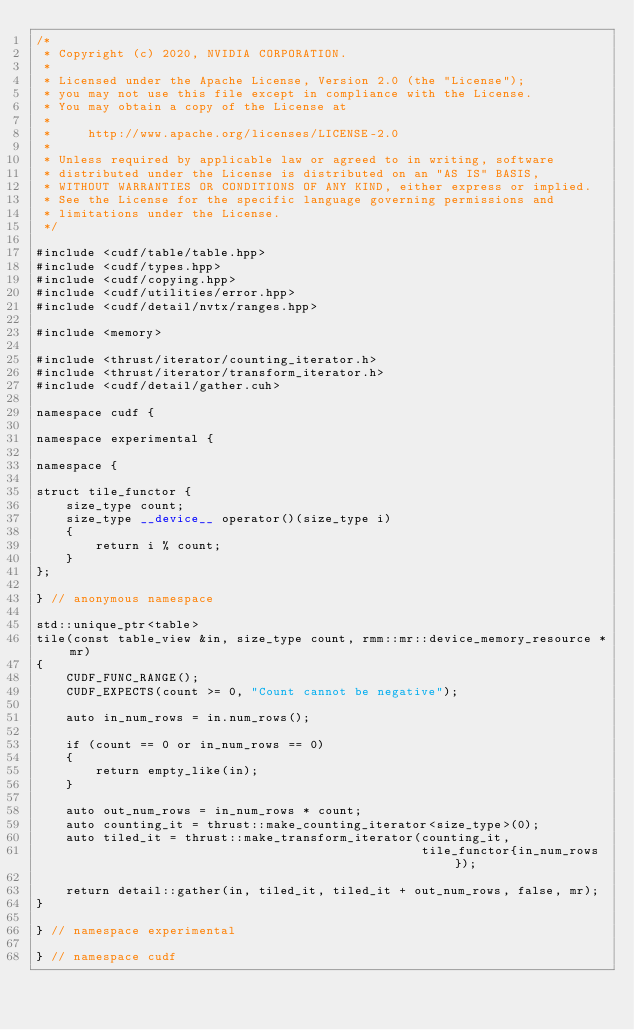Convert code to text. <code><loc_0><loc_0><loc_500><loc_500><_Cuda_>/*
 * Copyright (c) 2020, NVIDIA CORPORATION.
 *
 * Licensed under the Apache License, Version 2.0 (the "License");
 * you may not use this file except in compliance with the License.
 * You may obtain a copy of the License at
 *
 *     http://www.apache.org/licenses/LICENSE-2.0
 *
 * Unless required by applicable law or agreed to in writing, software
 * distributed under the License is distributed on an "AS IS" BASIS,
 * WITHOUT WARRANTIES OR CONDITIONS OF ANY KIND, either express or implied.
 * See the License for the specific language governing permissions and
 * limitations under the License.
 */

#include <cudf/table/table.hpp>
#include <cudf/types.hpp>
#include <cudf/copying.hpp>
#include <cudf/utilities/error.hpp>
#include <cudf/detail/nvtx/ranges.hpp>

#include <memory>

#include <thrust/iterator/counting_iterator.h>
#include <thrust/iterator/transform_iterator.h>
#include <cudf/detail/gather.cuh>

namespace cudf {

namespace experimental {

namespace {

struct tile_functor {
    size_type count;
    size_type __device__ operator()(size_type i)
    {
        return i % count;
    }
};

} // anonymous namespace

std::unique_ptr<table>
tile(const table_view &in, size_type count, rmm::mr::device_memory_resource *mr)
{
    CUDF_FUNC_RANGE();
    CUDF_EXPECTS(count >= 0, "Count cannot be negative");

    auto in_num_rows = in.num_rows();

    if (count == 0 or in_num_rows == 0)
    {
        return empty_like(in);
    }

    auto out_num_rows = in_num_rows * count;
    auto counting_it = thrust::make_counting_iterator<size_type>(0);
    auto tiled_it = thrust::make_transform_iterator(counting_it,
                                                    tile_functor{in_num_rows});

    return detail::gather(in, tiled_it, tiled_it + out_num_rows, false, mr);
}

} // namespace experimental

} // namespace cudf</code> 